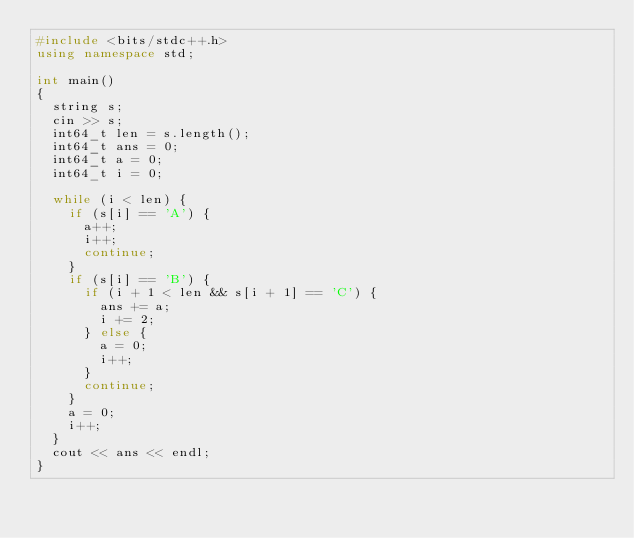<code> <loc_0><loc_0><loc_500><loc_500><_C++_>#include <bits/stdc++.h>
using namespace std;

int main()
{
  string s;
  cin >> s;
  int64_t len = s.length();
  int64_t ans = 0;
  int64_t a = 0;
  int64_t i = 0;

  while (i < len) {
    if (s[i] == 'A') {
      a++;
      i++;
      continue;
    }
    if (s[i] == 'B') {
      if (i + 1 < len && s[i + 1] == 'C') {
        ans += a;
        i += 2;
      } else {
        a = 0;
        i++;
      }
      continue;
    }
    a = 0;
    i++;
  }
  cout << ans << endl;
}
</code> 